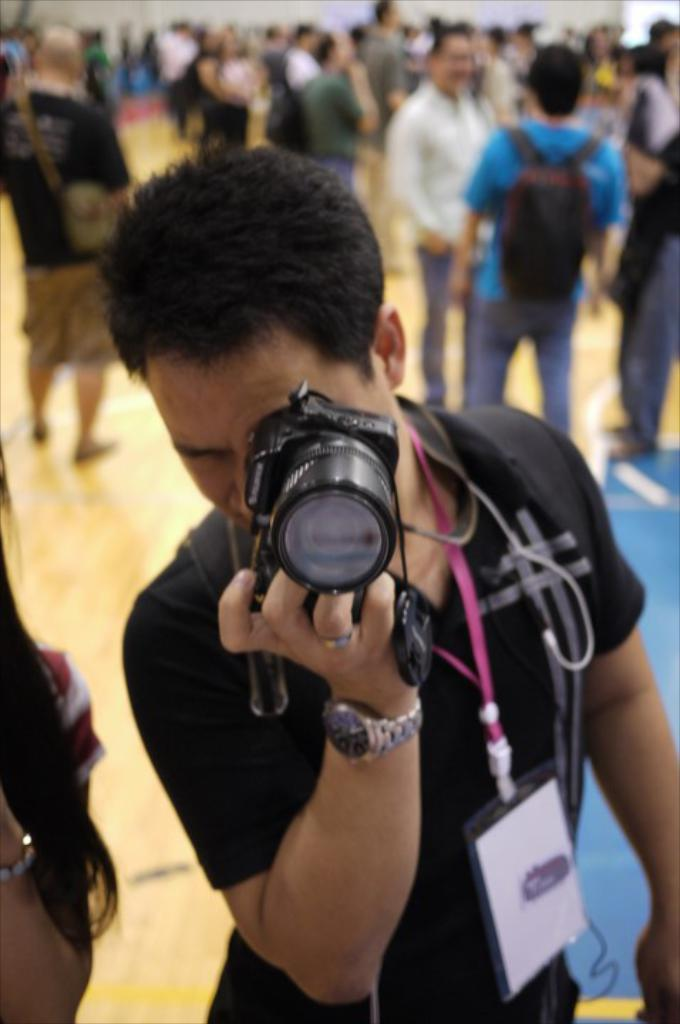What is the main subject of the image? The main subject of the image is a guy. What is the guy wearing in the image? The guy is wearing a black dress in the image. What is the guy holding in the image? The guy is holding a camera in the image. What is the guy doing with the camera? The guy is taking a picture with the camera in the image. Are there any other people visible in the image? Yes, there are people standing behind the guy in the image. What type of lizards can be seen talking to each other in the image? There are no lizards present in the image, and therefore no such conversation can be observed. 